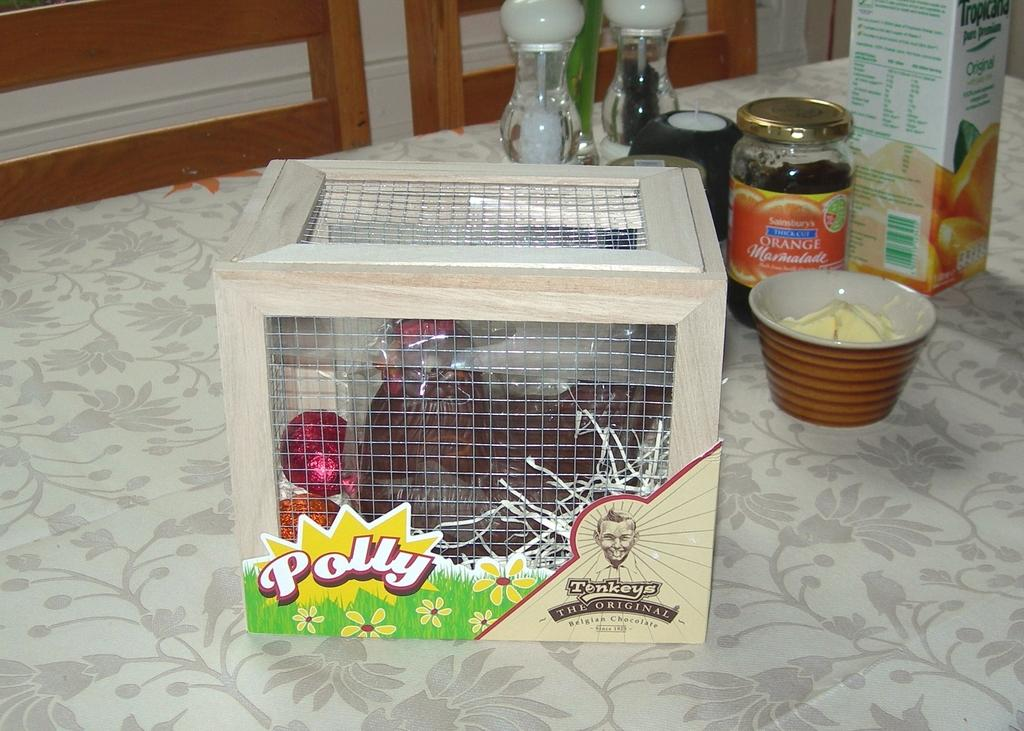<image>
Give a short and clear explanation of the subsequent image. A doll named Polly is sitting in a crate on a counter. 